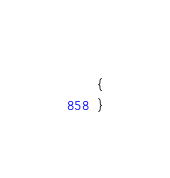<code> <loc_0><loc_0><loc_500><loc_500><_C++_>{
}
</code> 